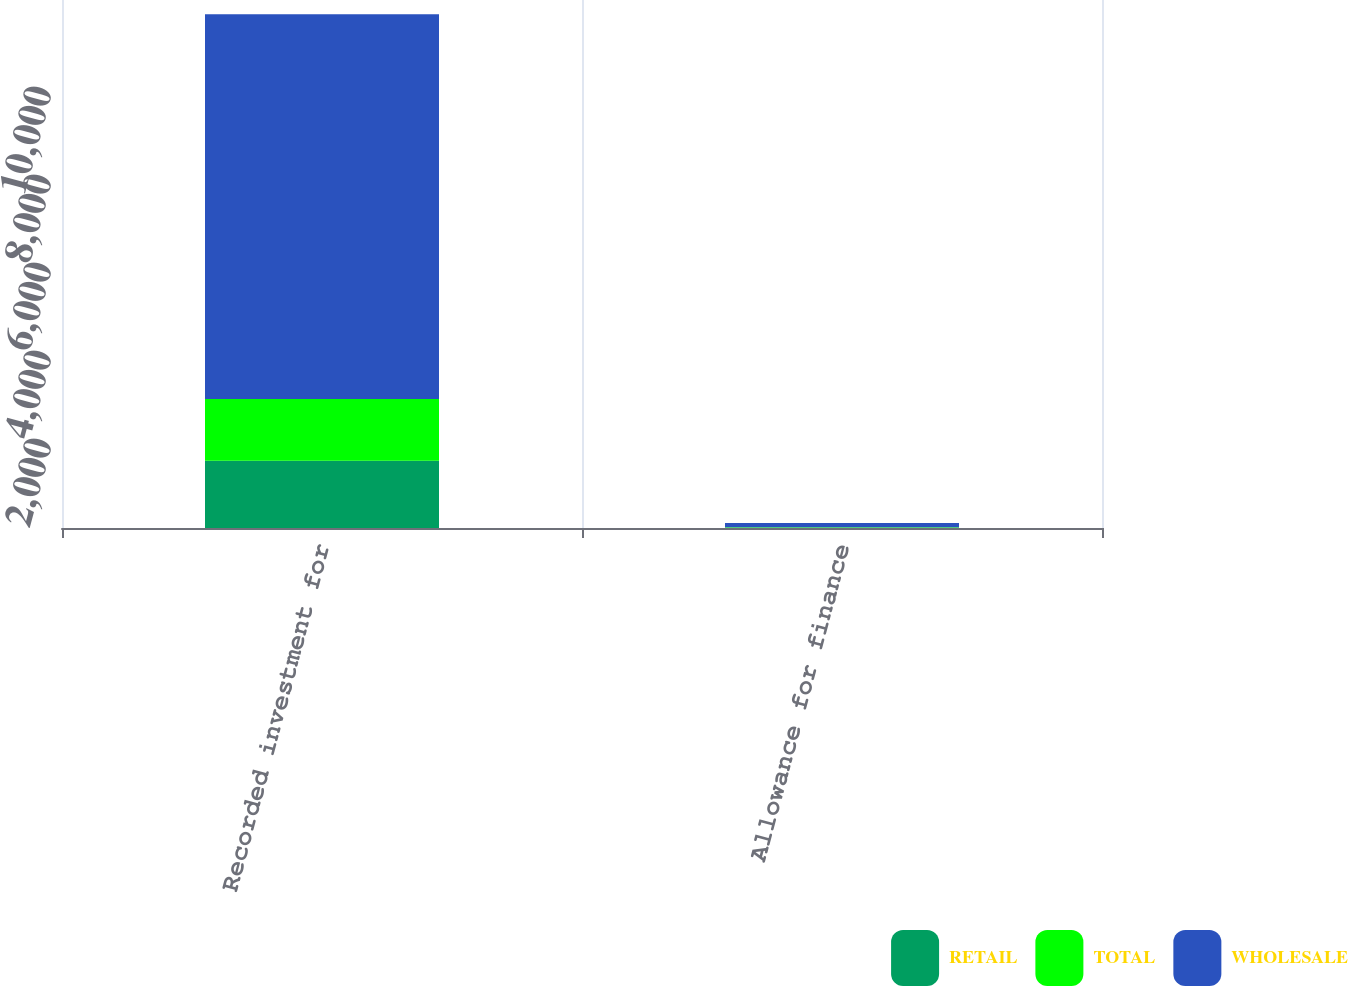Convert chart to OTSL. <chart><loc_0><loc_0><loc_500><loc_500><stacked_bar_chart><ecel><fcel>Recorded investment for<fcel>Allowance for finance<nl><fcel>RETAIL<fcel>1528.4<fcel>5.4<nl><fcel>TOTAL<fcel>1406<fcel>9.6<nl><fcel>WHOLESALE<fcel>8740.3<fcel>97.6<nl></chart> 